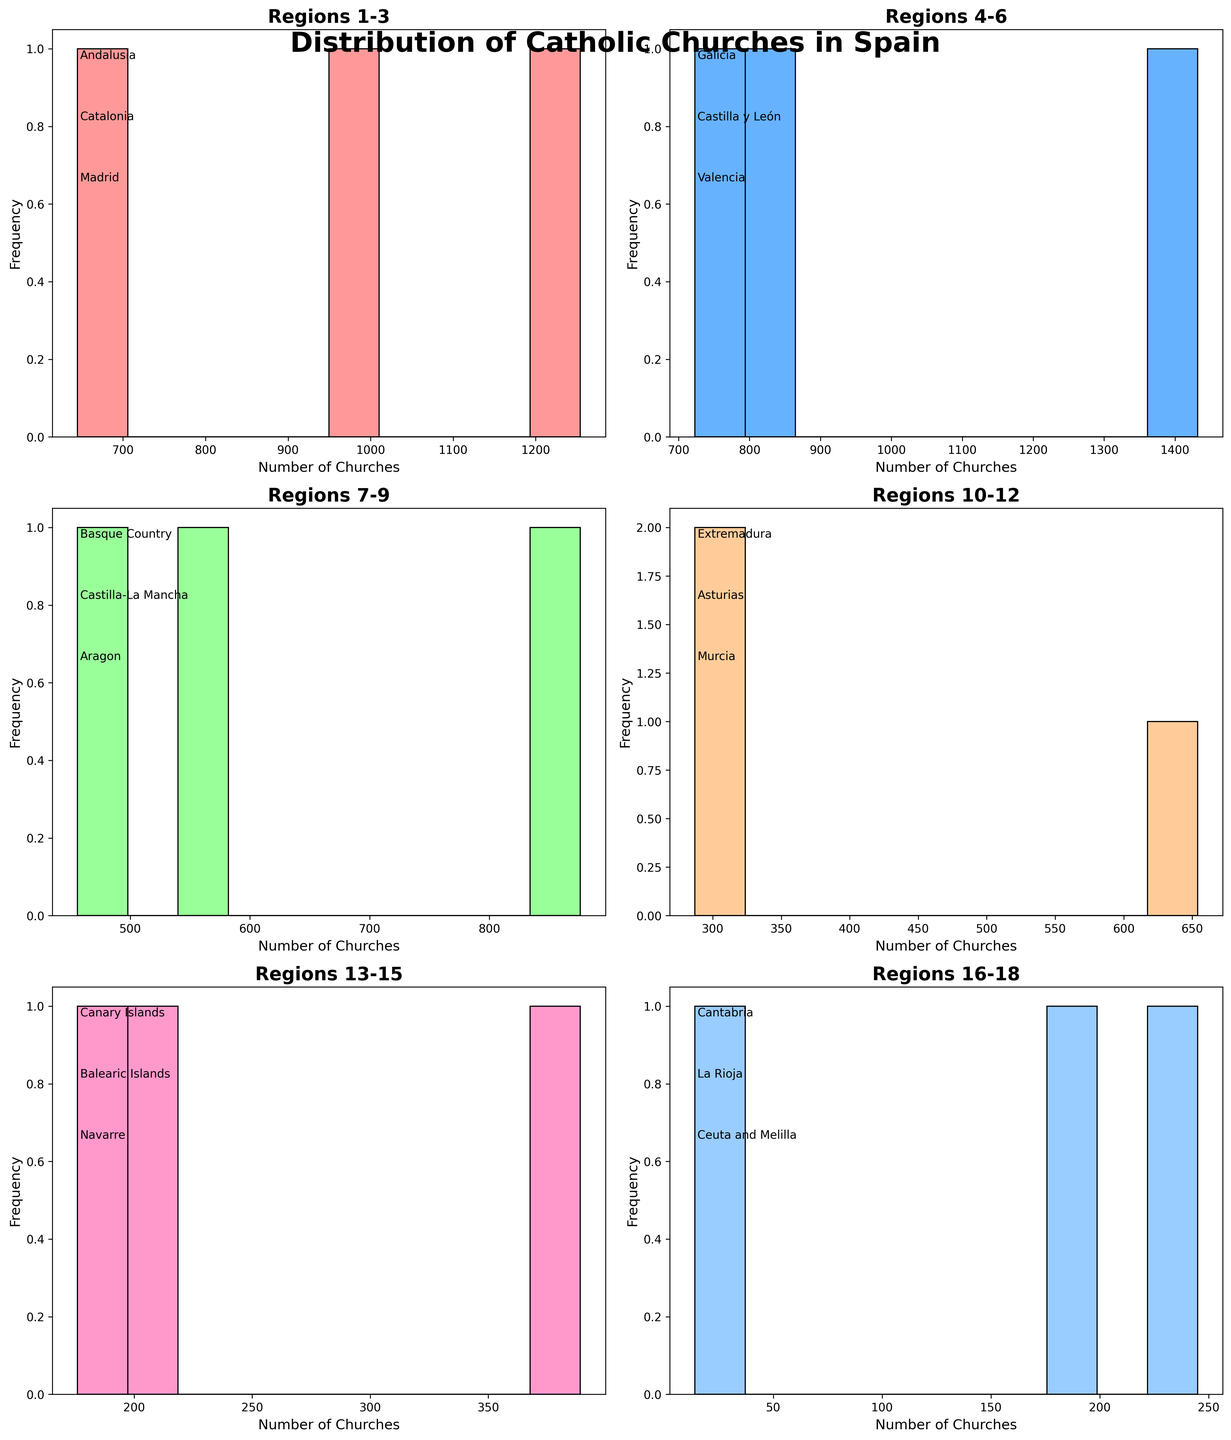What is the title of the figure? The title is located at the top center of the figure and it reads 'Distribution of Catholic Churches in Spain'.
Answer: Distribution of Catholic Churches in Spain Which region has the highest number of Catholic churches in the second subplot (Regions 4-6)? The second subplot corresponds to Regions 4-6. From the text labels in the plot, we see Galicia, Castilla y León, and Valencia are the regions. Among them, Castilla y León has the highest bar representing 1432 churches.
Answer: Castilla y León How many subplots are present in the figure? The figure contains a matrix of subplots (3 rows by 2 columns), which totals to 6 subplots.
Answer: 6 Compare the frequency of regions with fewer than 500 churches in the fourth and fifth subplots. Which one has more regions with less than 500 churches? Fourth subplot (Regions 10-12) includes Extremadura, Asturias, and Murcia. Fifth subplot (Regions 13-15) includes Canary Islands, Balearic Islands, and Navarre. Fourth subplot has no regions with fewer than 500 churches while the fifth subplot has Canary Islands and Balearic Islands, thus the fifth has more.
Answer: Fifth subplot Between the regions in the first subplot (Regions 1-3), which one has the smallest number of Catholic churches? The first subplot corresponds to Regions 1-3, which includes Andalusia, Catalonia, and Madrid. Madrid has the smallest number of churches indicated by the shortest bar, which is 645.
Answer: Madrid What is the range of the number of churches in the subplots covering regions 13 to 18? Regions 13 to 18 cover Canary Islands, Balearic Islands, Navarre, Cantabria, La Rioja, and Ceuta and Melilla. The smallest number is 14 (Ceuta and Melilla) and the largest is 389 (Navarre), thus the range is 389 - 14 = 375.
Answer: 375 